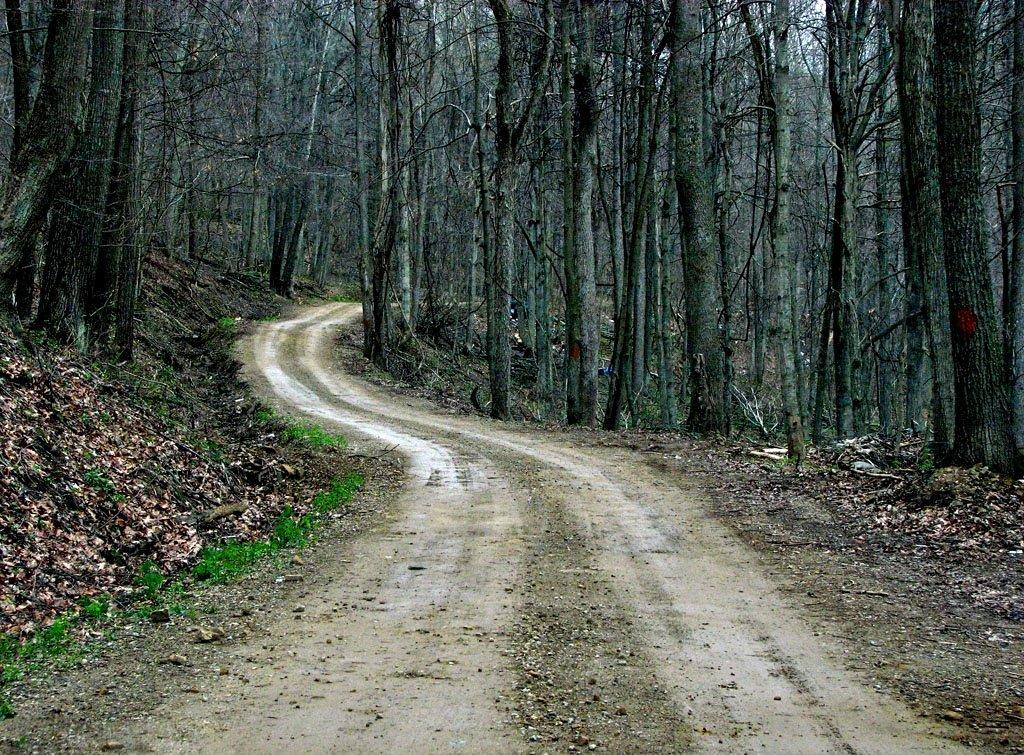What type of vegetation can be seen in the image? There are trees in the image. What part of the natural environment is visible in the image? The sky is visible in the image. What can be found on the ground in the image? There are shredded leaves and grass present in the image. What type of man-made structure is visible in the image? There is a road in the image. How many brothers are visible in the image? There are no brothers present in the image. What type of bit is being used to eat the leaves in the image? There is no bit present in the image, as the leaves are shredded and not being eaten. 